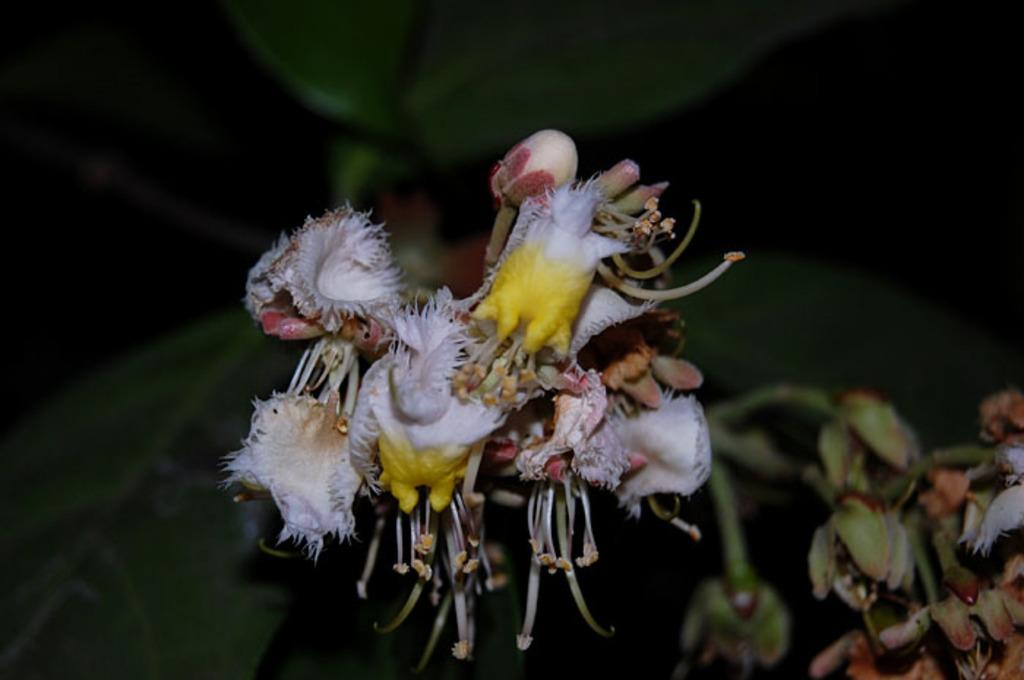What type of plant can be seen in the image? There is a flower plant in the image. What time of day is the brother using the quill to write a letter in the image? There is no brother or quill present in the image, and therefore no such activity can be observed. 